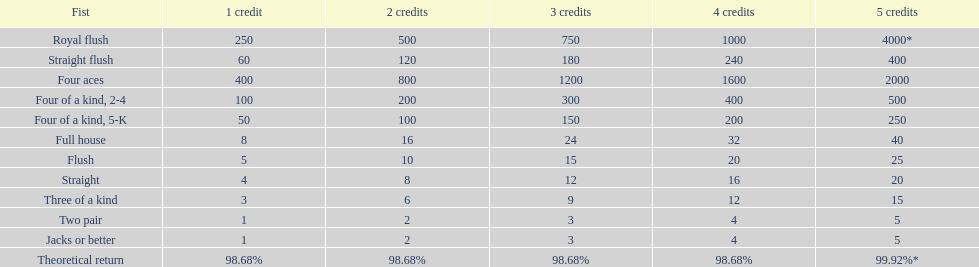Could you parse the entire table as a dict? {'header': ['Fist', '1 credit', '2 credits', '3 credits', '4 credits', '5 credits'], 'rows': [['Royal flush', '250', '500', '750', '1000', '4000*'], ['Straight flush', '60', '120', '180', '240', '400'], ['Four aces', '400', '800', '1200', '1600', '2000'], ['Four of a kind, 2-4', '100', '200', '300', '400', '500'], ['Four of a kind, 5-K', '50', '100', '150', '200', '250'], ['Full house', '8', '16', '24', '32', '40'], ['Flush', '5', '10', '15', '20', '25'], ['Straight', '4', '8', '12', '16', '20'], ['Three of a kind', '3', '6', '9', '12', '15'], ['Two pair', '1', '2', '3', '4', '5'], ['Jacks or better', '1', '2', '3', '4', '5'], ['Theoretical return', '98.68%', '98.68%', '98.68%', '98.68%', '99.92%*']]} Which hand is the top hand in the card game super aces? Royal flush. 